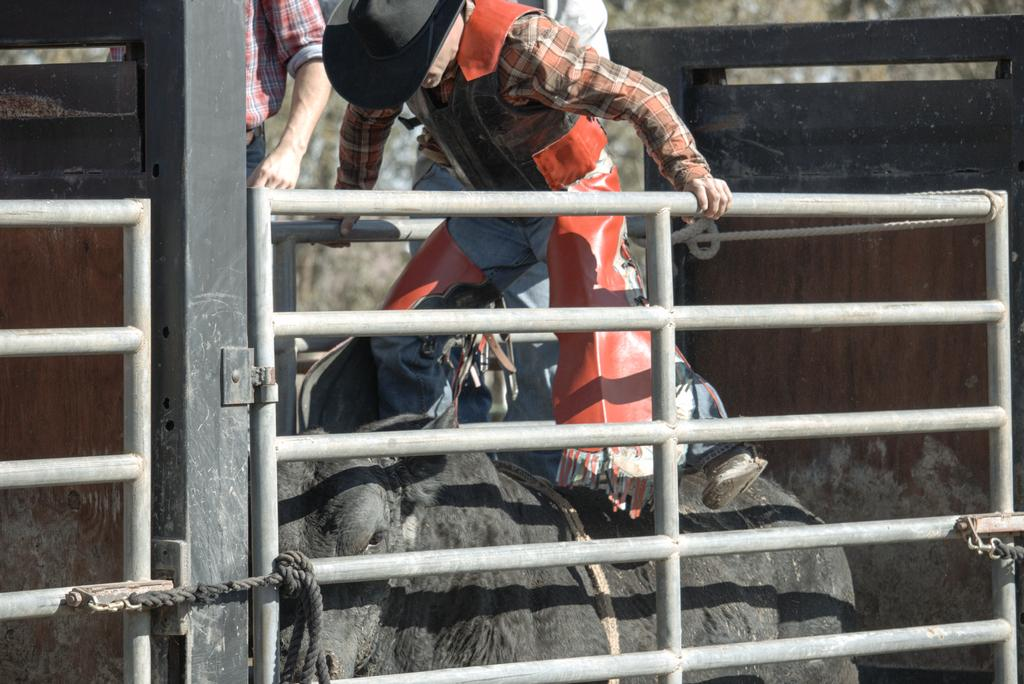What objects can be seen in the image? There are rods and rope in the image. What living beings are present in the image? There are people and an animal in the image. What type of learning is the animal undergoing in the image? There is no indication of any learning taking place in the image; the animal is simply present. 